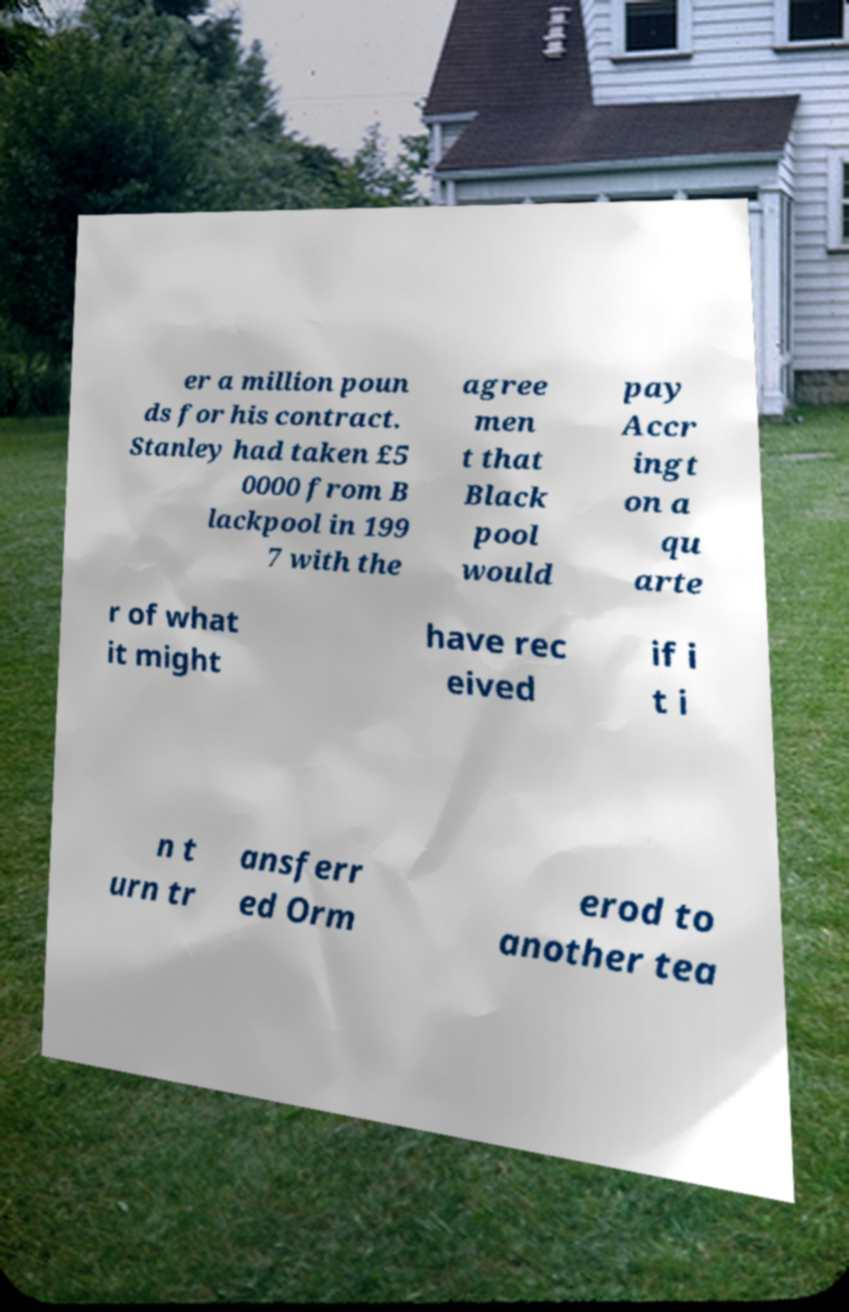For documentation purposes, I need the text within this image transcribed. Could you provide that? er a million poun ds for his contract. Stanley had taken £5 0000 from B lackpool in 199 7 with the agree men t that Black pool would pay Accr ingt on a qu arte r of what it might have rec eived if i t i n t urn tr ansferr ed Orm erod to another tea 